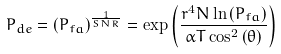<formula> <loc_0><loc_0><loc_500><loc_500>P _ { d e } = \left ( P _ { f a } \right ) ^ { \frac { 1 } { S N R } } = \exp \left ( \frac { r ^ { 4 } N \ln \left ( P _ { f a } \right ) } { \alpha T \cos ^ { 2 } \left ( \theta \right ) } \right )</formula> 